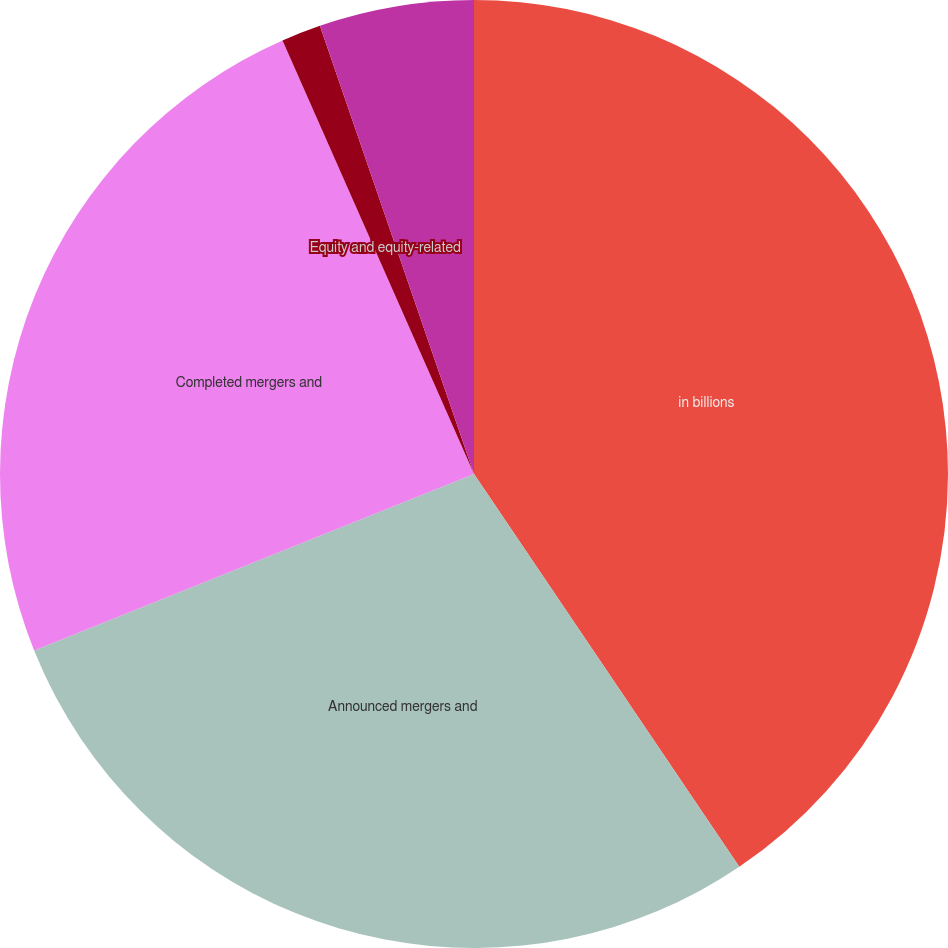Convert chart to OTSL. <chart><loc_0><loc_0><loc_500><loc_500><pie_chart><fcel>in billions<fcel>Announced mergers and<fcel>Completed mergers and<fcel>Equity and equity-related<fcel>Debt offerings<nl><fcel>40.55%<fcel>28.38%<fcel>24.46%<fcel>1.35%<fcel>5.27%<nl></chart> 